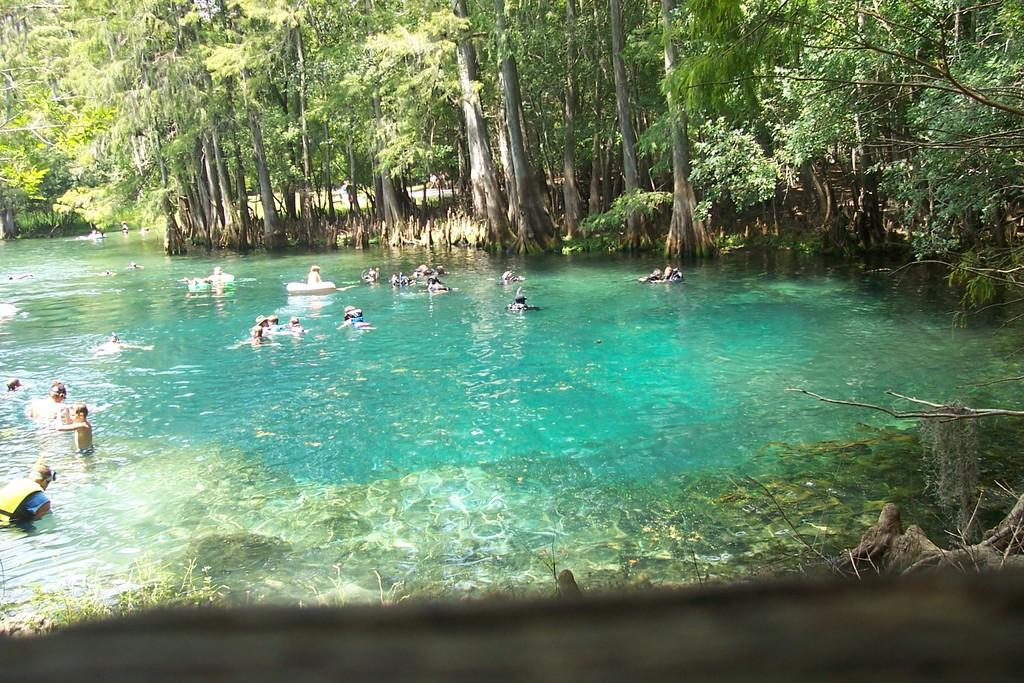What are the people in the image doing? There are people swimming in the river. What can be seen in the background of the image? There are many trees around the river. How many chairs are placed near the river in the image? There are no chairs visible in the image; people are swimming in the river. What type of farming equipment can be seen in the image? There is no farming equipment, such as a plough, present in the image. 